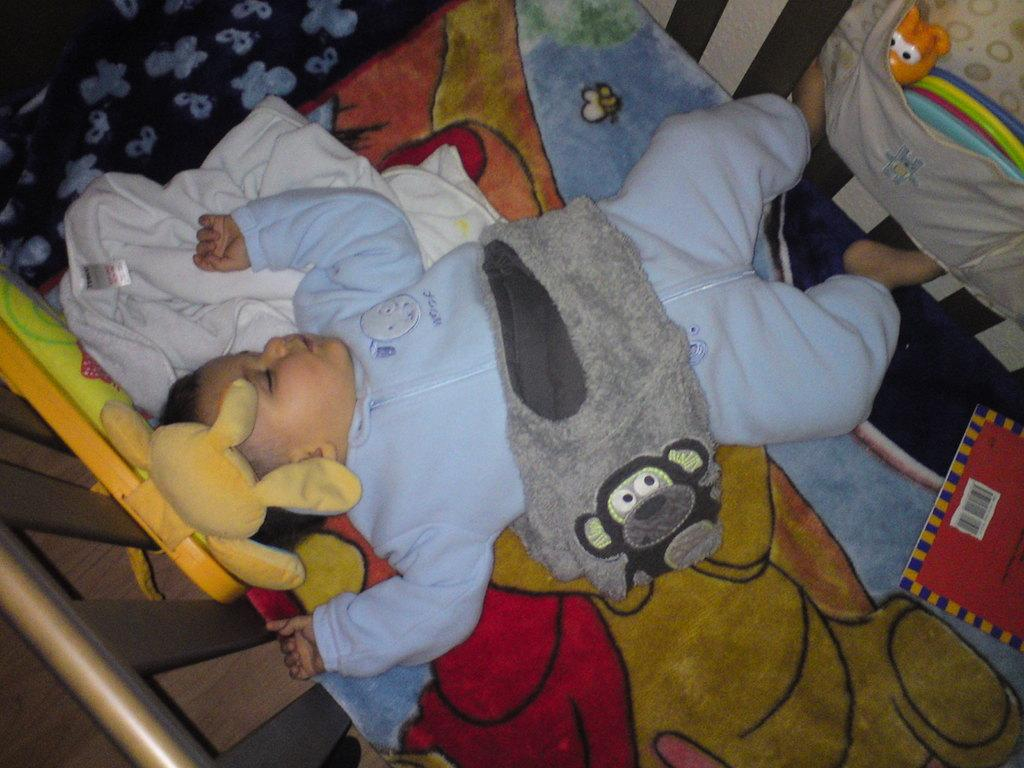What is the main subject of the image? There is a baby sleeping in a cradle in the image. Can you describe the person mentioned in the image? The person is wearing a sky blue color sweater. What object can be seen on the right side of the image? There is a book on the right side of the image. What type of transport can be seen in the image? There is no transport visible in the image; it features a baby sleeping in a cradle and a person wearing a sky blue sweater. Is there any water visible in the image? No, there is no water present in the image. 